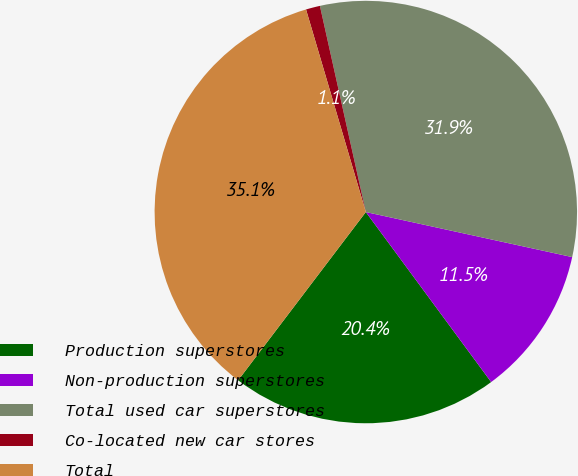Convert chart to OTSL. <chart><loc_0><loc_0><loc_500><loc_500><pie_chart><fcel>Production superstores<fcel>Non-production superstores<fcel>Total used car superstores<fcel>Co-located new car stores<fcel>Total<nl><fcel>20.44%<fcel>11.47%<fcel>31.91%<fcel>1.08%<fcel>35.1%<nl></chart> 